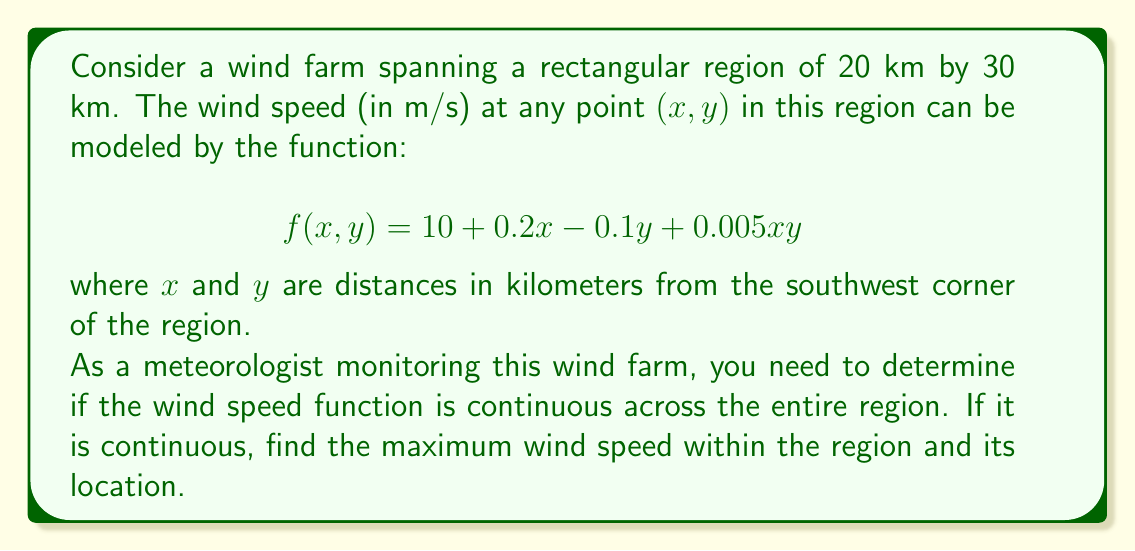Give your solution to this math problem. To solve this problem, we'll follow these steps:

1. Determine if the function is continuous:
   The given function $f(x,y) = 10 + 0.2x - 0.1y + 0.005xy$ is a polynomial function in x and y. Polynomial functions are always continuous over their entire domain. Since x and y represent real distances, the function is defined and continuous for all real numbers, including our region of interest.

2. Find the maximum wind speed:
   To find the maximum wind speed, we need to find the critical points of the function within the region and evaluate the function at these points and the boundaries.

   a) Find partial derivatives:
      $$\frac{\partial f}{\partial x} = 0.2 + 0.005y$$
      $$\frac{\partial f}{\partial y} = -0.1 + 0.005x$$

   b) Set partial derivatives to zero and solve:
      $$0.2 + 0.005y = 0 \implies y = -40$$
      $$-0.1 + 0.005x = 0 \implies x = 20$$

   The critical point (20, -40) lies outside our region, so we only need to check the boundaries.

   c) Evaluate f(x,y) at the corners of the region:
      Southwest corner: f(0, 0) = 10
      Northwest corner: f(0, 30) = 7
      Southeast corner: f(20, 0) = 14
      Northeast corner: f(20, 30) = 14

   The maximum value occurs at the Southeast and Northeast corners.

3. Determine the location of the maximum wind speed:
   The maximum wind speed occurs along the entire eastern edge of the region, where x = 20 and y ranges from 0 to 30.
Answer: The wind speed function is continuous across the entire region. The maximum wind speed is 14 m/s, occurring along the eastern edge of the region where x = 20 km and y ranges from 0 to 30 km. 